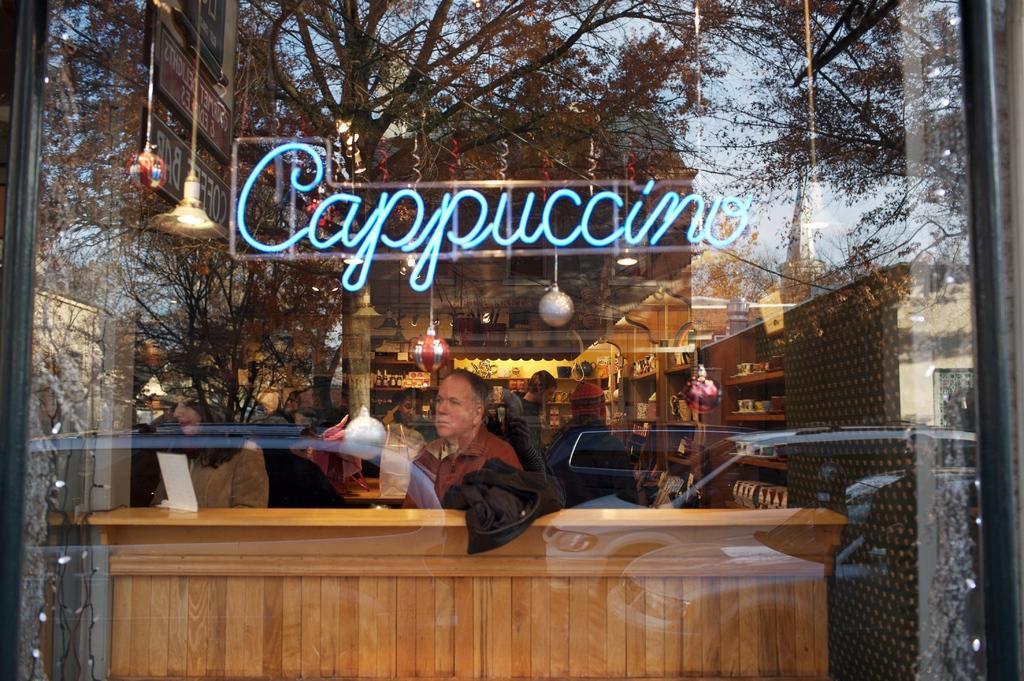How would you summarize this image in a sentence or two? In this image I see the transparent glass and I see many people and I see groceries in the racks and I see a word over here and I see the decoration and the lights. 